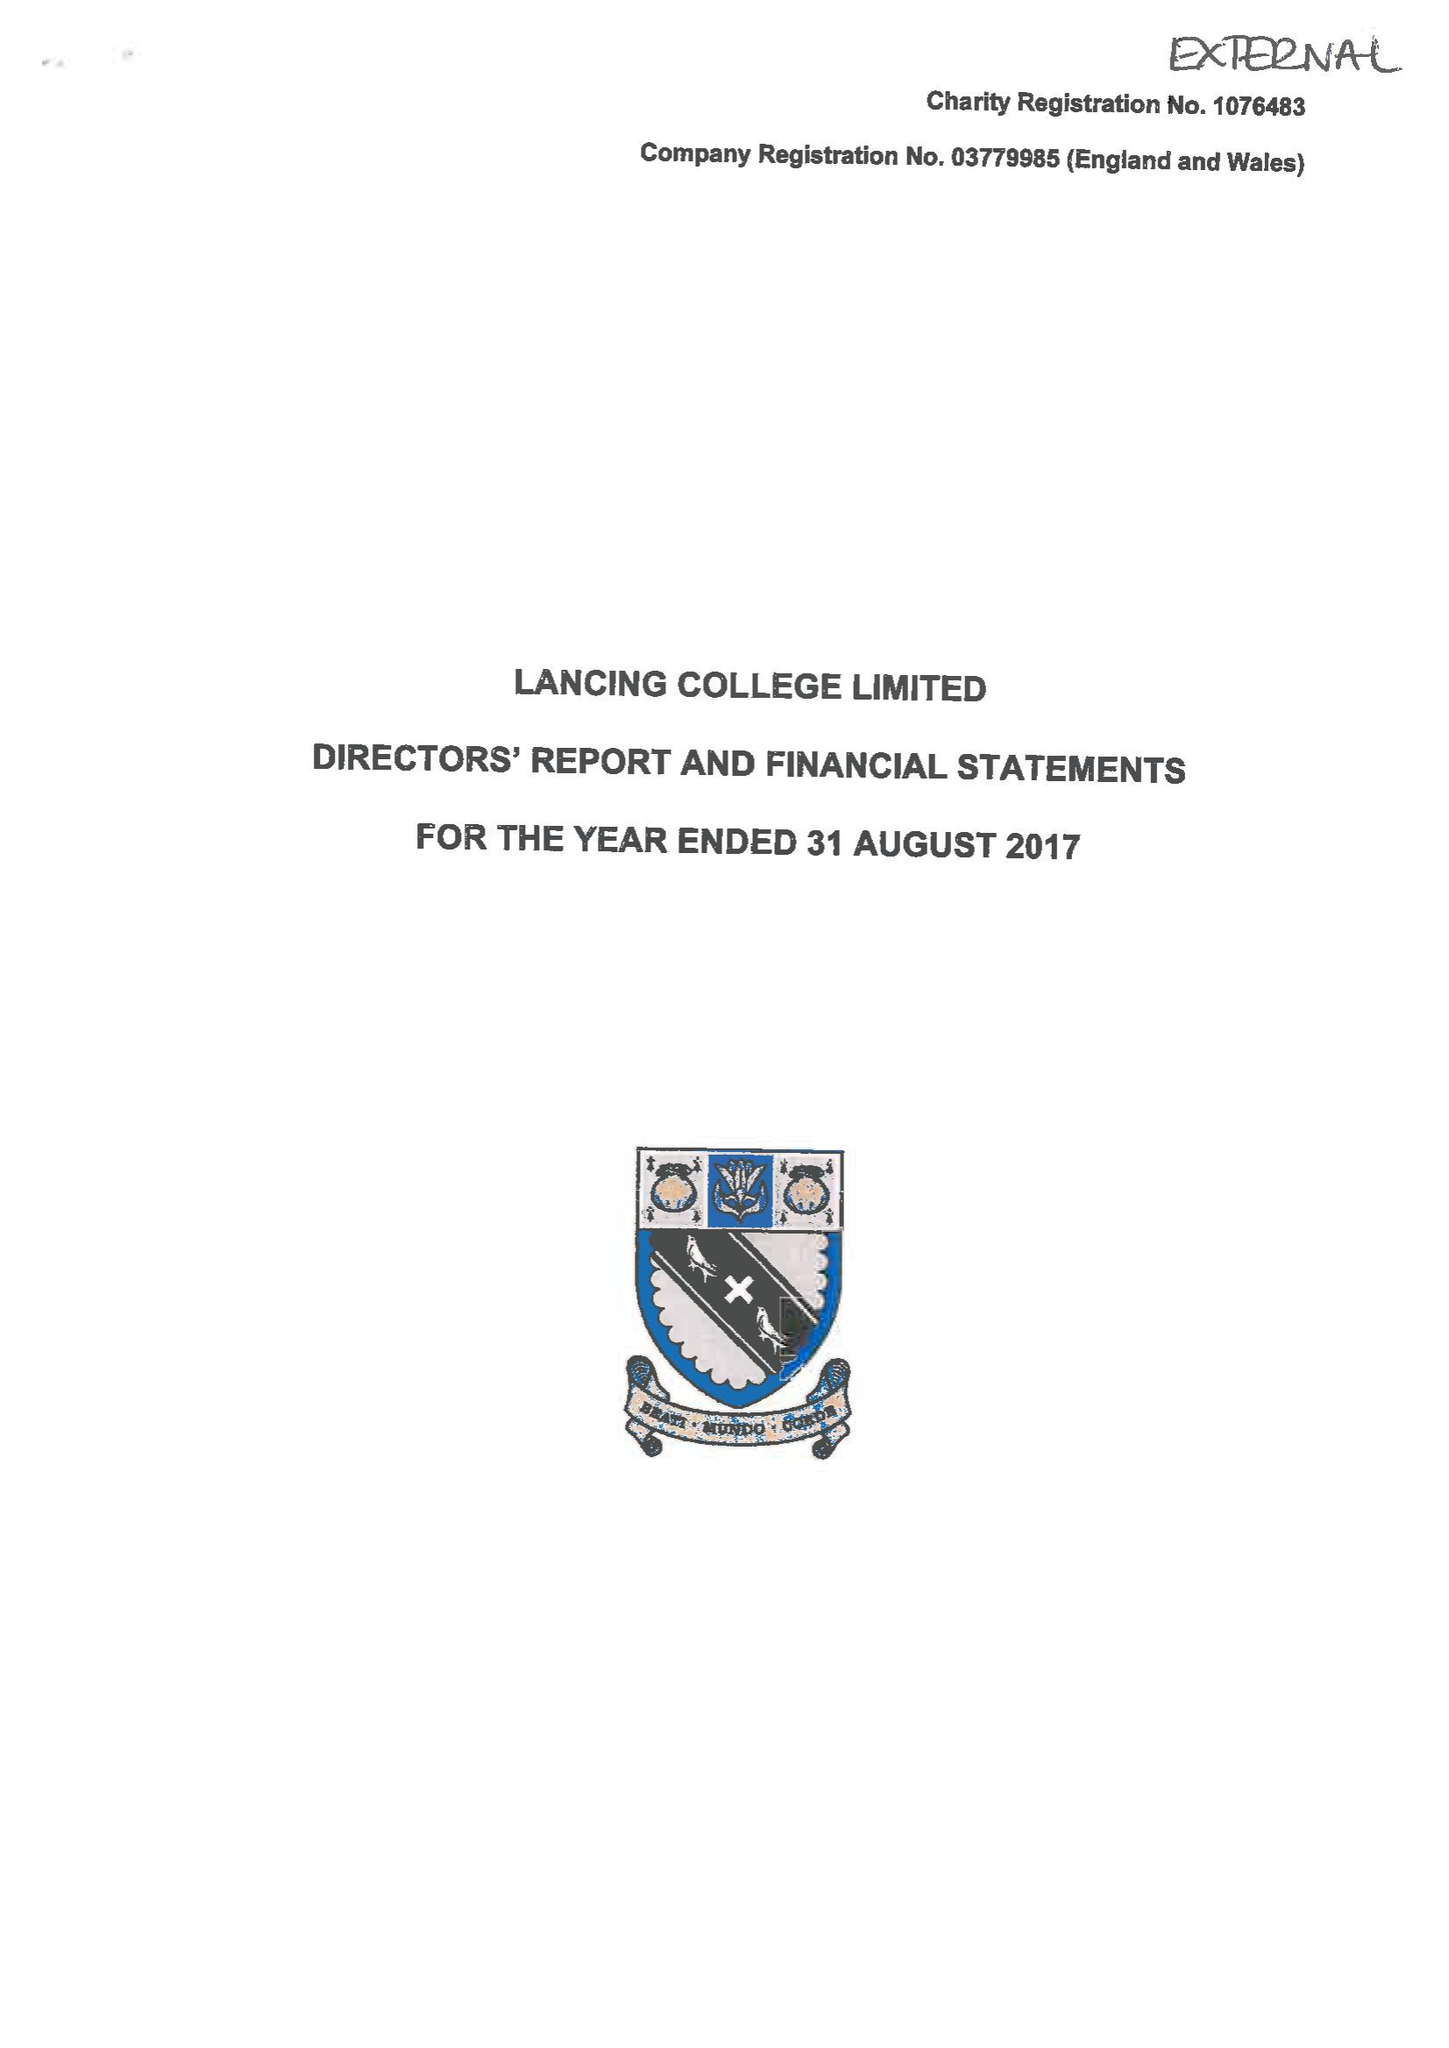What is the value for the income_annually_in_british_pounds?
Answer the question using a single word or phrase. 21321748.00 